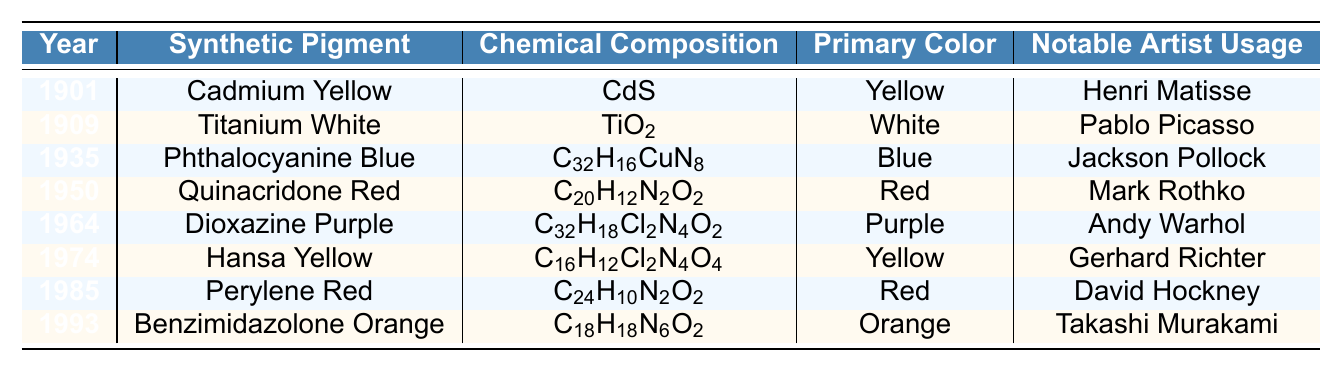What synthetic pigment was introduced in 1901? The table shows the year of introduction next to the synthetic pigments. In 1901, Cadmium Yellow is listed as the synthetic pigment.
Answer: Cadmium Yellow Which synthetic pigment has a chemical composition of C32H16CuN8? By locating the chemical composition in the table, it can be seen that C32H16CuN8 corresponds to Phthalocyanine Blue, which is noted in the year 1935.
Answer: Phthalocyanine Blue How many synthetic pigments listed in the table are primarily red? The table shows that there are two red pigments: Quinacridone Red (1950) and Perylene Red (1985). Counting these gives a total of 2.
Answer: 2 What is the primary color of the synthetic pigment used by Andy Warhol? By checking the notable artist usage and the corresponding primary color, it is identified that the pigment used by Andy Warhol, which is Dioxazine Purple (1964), has the primary color purple.
Answer: Purple Is Titanium White used by Gerhard Richter according to the table? The table lists Gerhard Richter as the notable artist for Hansa Yellow, while Titanium White is attributed to Pablo Picasso. Therefore, the statement is false.
Answer: No Which color appears first chronologically in the development of synthetic pigments? Looking at the years in the table, yellow (Cadmium Yellow, 1901) is the earliest synthetic pigment listed before any other colors.
Answer: Yellow What is the last synthetic pigment introduced in the table? By examining the years in the table, the latest year is 1993, which corresponds to Benzimidazolone Orange as the last synthetic pigment.
Answer: Benzimidazolone Orange Which notable artist used both red synthetic pigments? The artists Mark Rothko (for Quinacridone Red) and David Hockney (for Perylene Red) are both noted in the table, indicating they both worked with red pigments.
Answer: Mark Rothko and David Hockney Among the synthetic pigments listed, which one is most associated with the color orange? The table indicates that Benzimidazolone Orange is associated with the primary color orange, as seen in the last row.
Answer: Benzimidazolone Orange What is the average number of years between the introduction of these synthetic pigments? The range of years spans from 1901 to 1993, a total of 92 years, over 8 pigments. Thus, 92/8 = 11.5 years on average between each.
Answer: 11.5 years 